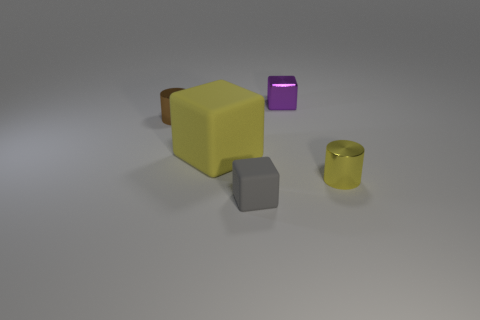Subtract all big yellow cubes. How many cubes are left? 2 Subtract all purple blocks. How many blocks are left? 2 Add 3 small rubber things. How many objects exist? 8 Subtract all red cubes. Subtract all blue balls. How many cubes are left? 3 Subtract all big objects. Subtract all brown shiny cylinders. How many objects are left? 3 Add 4 gray blocks. How many gray blocks are left? 5 Add 4 tiny metal blocks. How many tiny metal blocks exist? 5 Subtract 1 purple blocks. How many objects are left? 4 Subtract all cylinders. How many objects are left? 3 